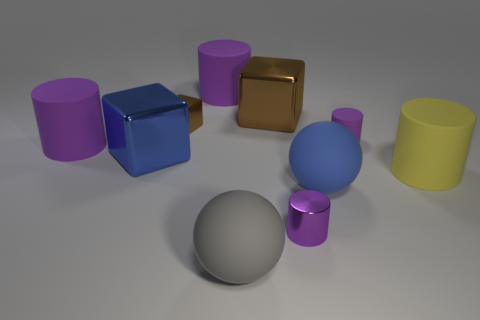The small cylinder in front of the large matte ball on the right side of the small purple thing that is left of the big blue matte ball is made of what material?
Your response must be concise. Metal. What number of things are large brown metallic cubes or matte spheres to the right of the large gray matte sphere?
Your response must be concise. 2. Do the small cylinder that is behind the big blue matte thing and the shiny cylinder have the same color?
Ensure brevity in your answer.  Yes. Are there more large metal blocks right of the small cube than big blue matte spheres that are behind the large blue matte ball?
Keep it short and to the point. Yes. Is there any other thing that is the same color as the small metal cylinder?
Give a very brief answer. Yes. What number of objects are either big rubber cylinders or blue spheres?
Provide a short and direct response. 4. Does the brown shiny cube that is on the right side of the gray matte object have the same size as the yellow matte thing?
Provide a short and direct response. Yes. What number of other things are there of the same size as the blue ball?
Keep it short and to the point. 6. Are there any big green rubber objects?
Your response must be concise. No. There is a brown shiny block in front of the large brown block on the right side of the tiny brown object; how big is it?
Offer a very short reply. Small. 